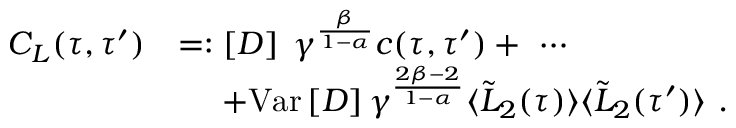Convert formula to latex. <formula><loc_0><loc_0><loc_500><loc_500>\begin{array} { r l } { C _ { L } ( \tau , \tau ^ { \prime } ) } & { = \colon \left [ D \right ] \, \gamma ^ { \frac { \beta } { 1 - \alpha } } c ( \tau , \tau ^ { \prime } ) + \ \cdots } \\ & { \quad \ + V a r \left [ D \right ] \gamma ^ { \frac { 2 \beta - 2 } { 1 - \alpha } } \langle \tilde { L } _ { 2 } ( \tau ) \rangle \langle \tilde { L } _ { 2 } ( \tau ^ { \prime } ) \rangle \ . } \end{array}</formula> 